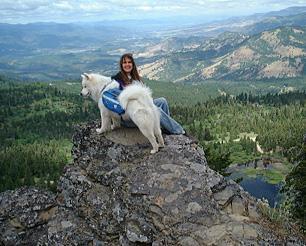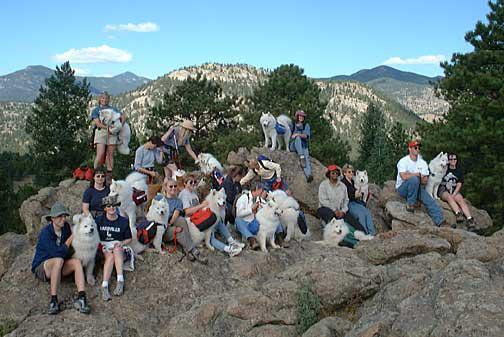The first image is the image on the left, the second image is the image on the right. Considering the images on both sides, is "White dogs are standing on a rocky edge." valid? Answer yes or no. Yes. The first image is the image on the left, the second image is the image on the right. Considering the images on both sides, is "AN image shows just one person posed behind one big white dog outdoors." valid? Answer yes or no. Yes. 